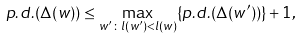<formula> <loc_0><loc_0><loc_500><loc_500>p . d . ( \Delta ( w ) ) \leq \max _ { w ^ { \prime } \colon l ( w ^ { \prime } ) < l ( w ) } \{ p . d . ( \Delta ( w ^ { \prime } ) ) \} + 1 ,</formula> 